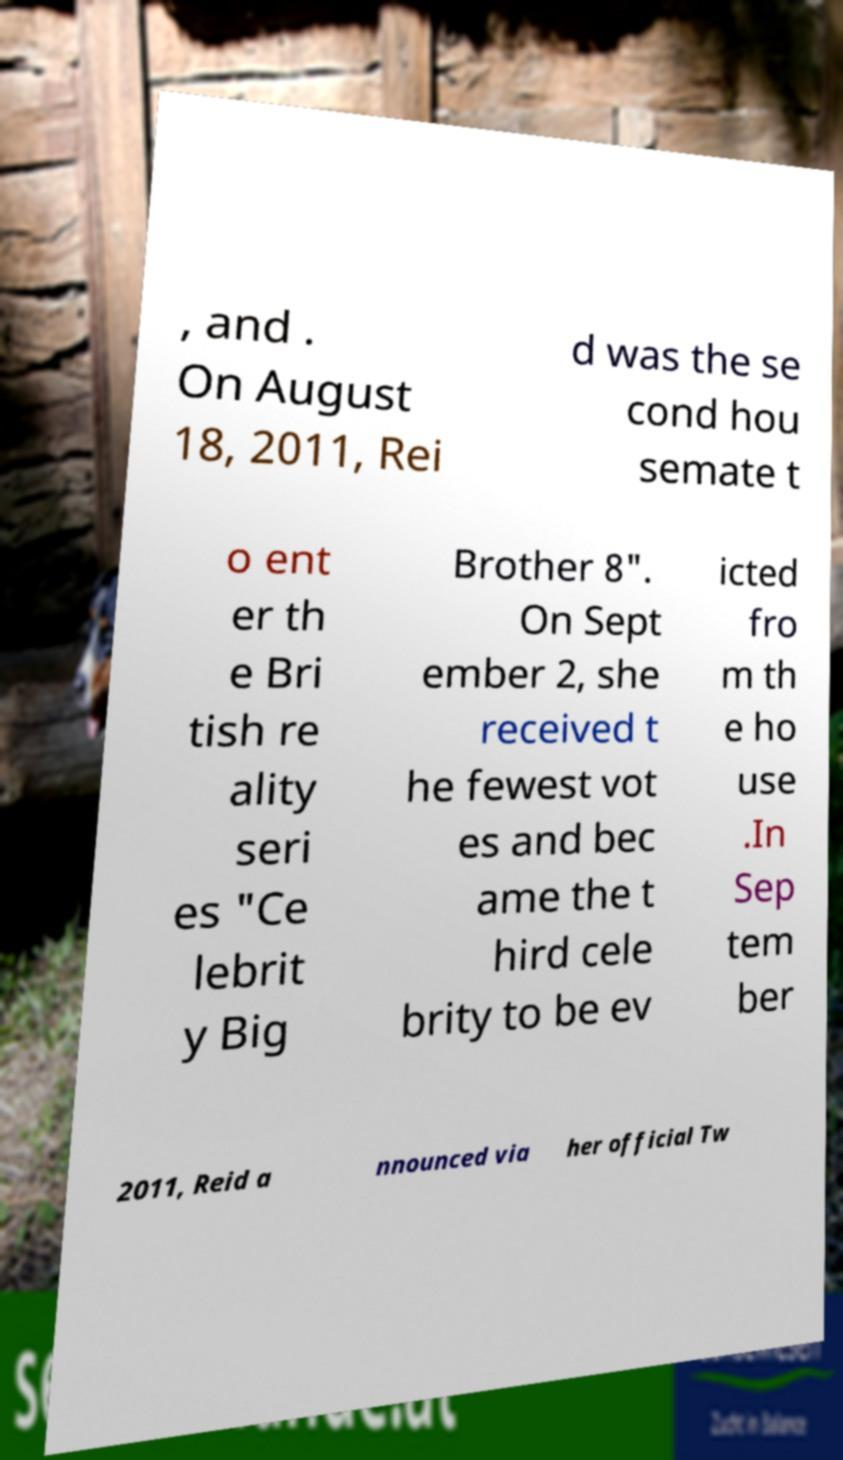Could you extract and type out the text from this image? , and . On August 18, 2011, Rei d was the se cond hou semate t o ent er th e Bri tish re ality seri es "Ce lebrit y Big Brother 8". On Sept ember 2, she received t he fewest vot es and bec ame the t hird cele brity to be ev icted fro m th e ho use .In Sep tem ber 2011, Reid a nnounced via her official Tw 